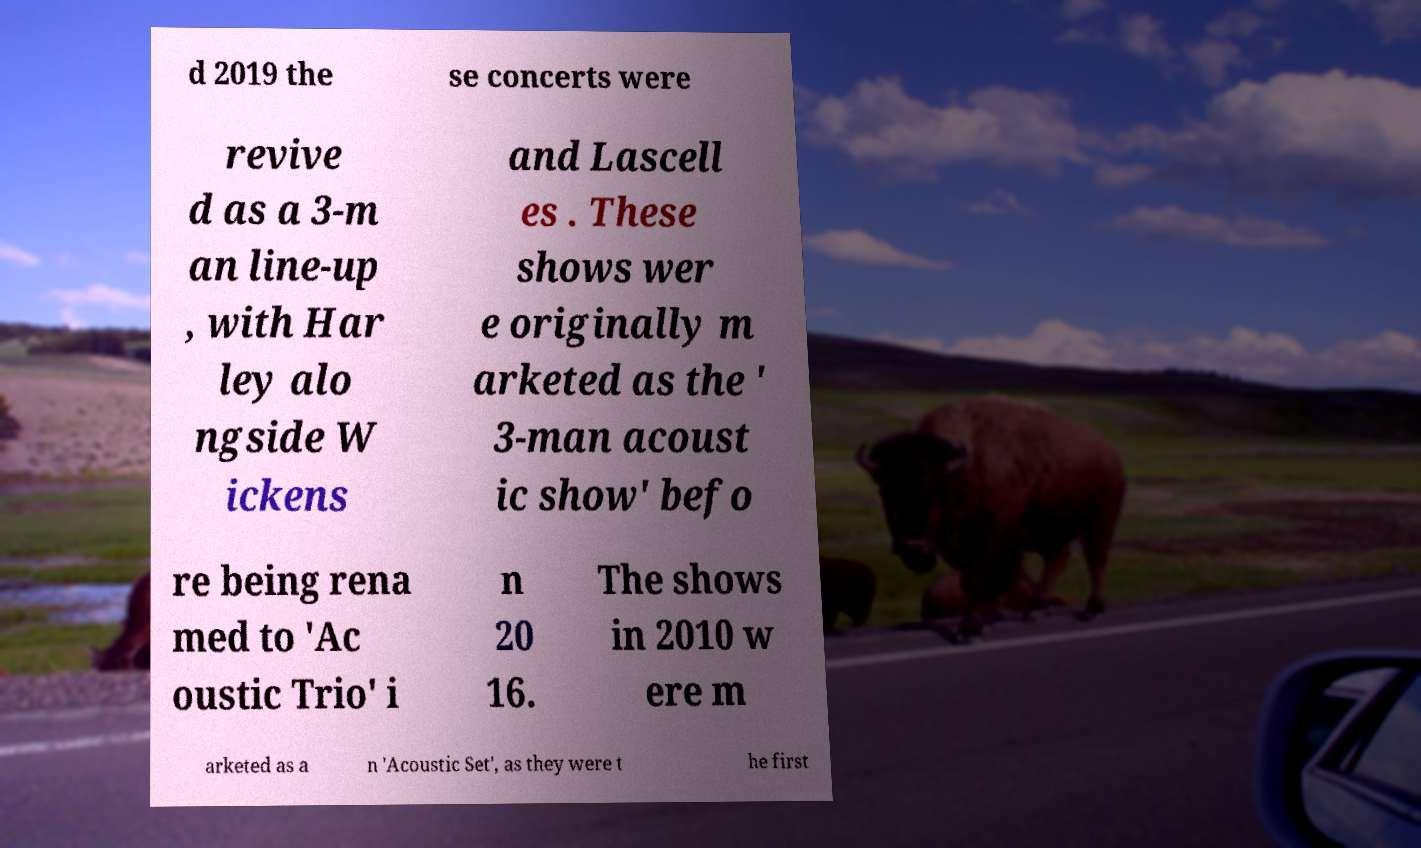Please identify and transcribe the text found in this image. d 2019 the se concerts were revive d as a 3-m an line-up , with Har ley alo ngside W ickens and Lascell es . These shows wer e originally m arketed as the ' 3-man acoust ic show' befo re being rena med to 'Ac oustic Trio' i n 20 16. The shows in 2010 w ere m arketed as a n 'Acoustic Set', as they were t he first 